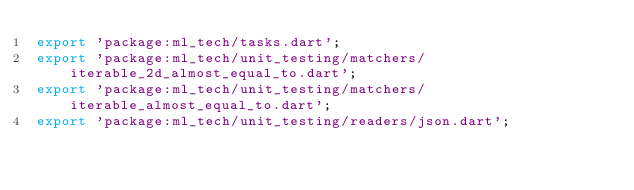Convert code to text. <code><loc_0><loc_0><loc_500><loc_500><_Dart_>export 'package:ml_tech/tasks.dart';
export 'package:ml_tech/unit_testing/matchers/iterable_2d_almost_equal_to.dart';
export 'package:ml_tech/unit_testing/matchers/iterable_almost_equal_to.dart';
export 'package:ml_tech/unit_testing/readers/json.dart';
</code> 